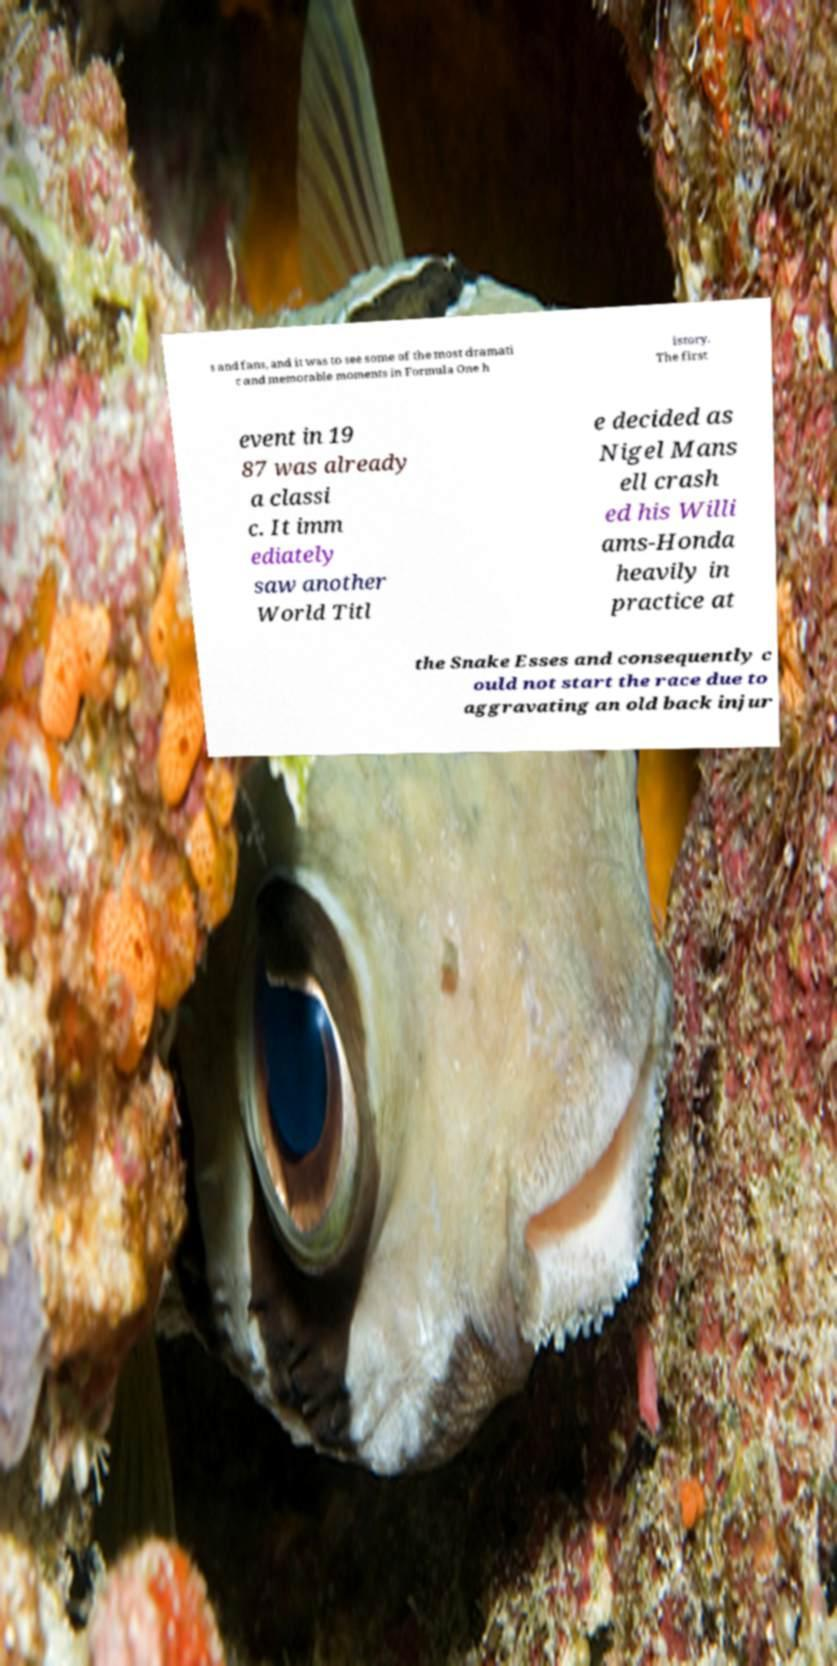Can you read and provide the text displayed in the image?This photo seems to have some interesting text. Can you extract and type it out for me? s and fans, and it was to see some of the most dramati c and memorable moments in Formula One h istory. The first event in 19 87 was already a classi c. It imm ediately saw another World Titl e decided as Nigel Mans ell crash ed his Willi ams-Honda heavily in practice at the Snake Esses and consequently c ould not start the race due to aggravating an old back injur 